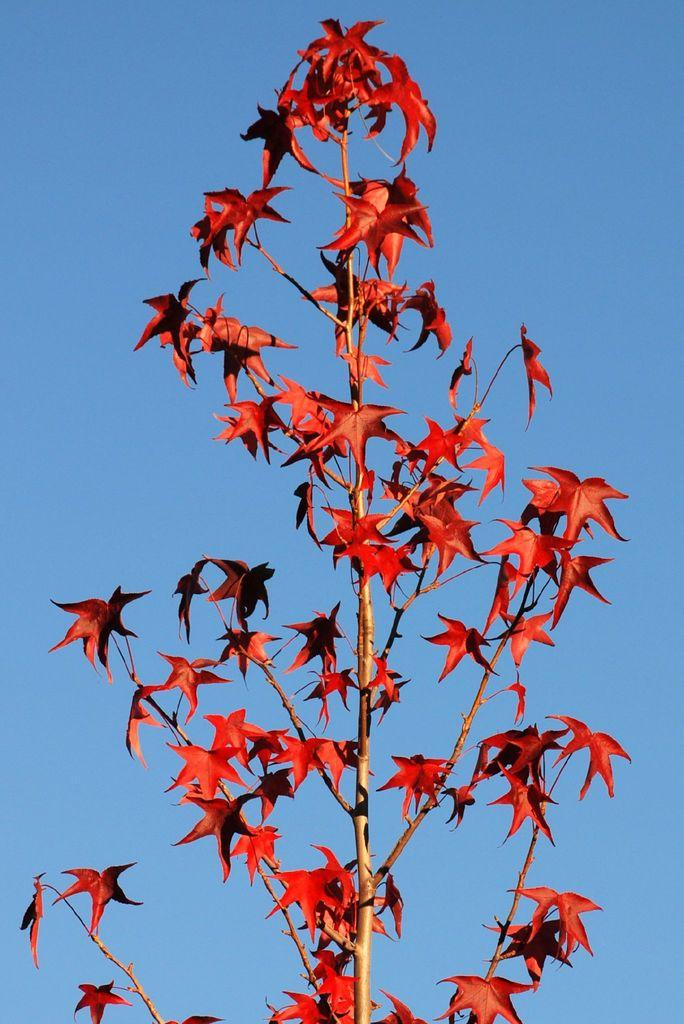What is present in the image? There is a tree in the image. Can you describe the tree in the image? The tree has leaves. What language is the writing on the tree in the image? There is no writing on the tree in the image. 